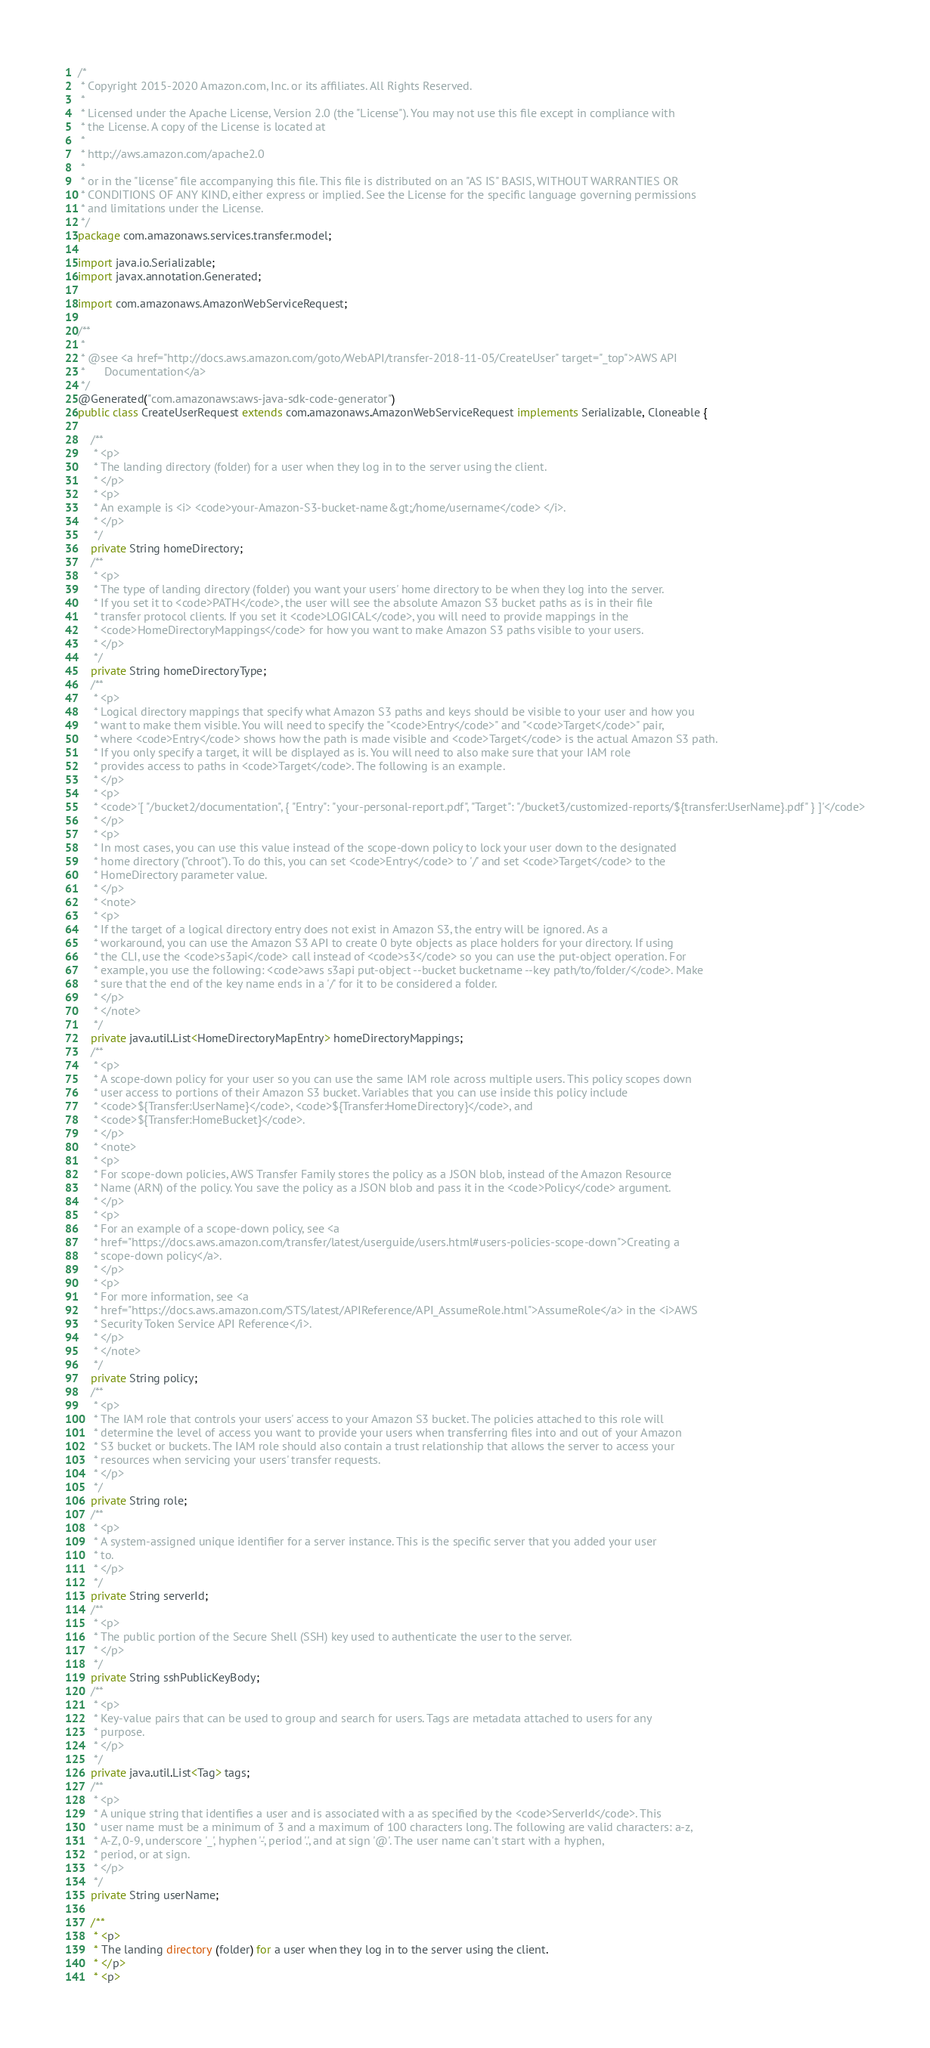<code> <loc_0><loc_0><loc_500><loc_500><_Java_>/*
 * Copyright 2015-2020 Amazon.com, Inc. or its affiliates. All Rights Reserved.
 * 
 * Licensed under the Apache License, Version 2.0 (the "License"). You may not use this file except in compliance with
 * the License. A copy of the License is located at
 * 
 * http://aws.amazon.com/apache2.0
 * 
 * or in the "license" file accompanying this file. This file is distributed on an "AS IS" BASIS, WITHOUT WARRANTIES OR
 * CONDITIONS OF ANY KIND, either express or implied. See the License for the specific language governing permissions
 * and limitations under the License.
 */
package com.amazonaws.services.transfer.model;

import java.io.Serializable;
import javax.annotation.Generated;

import com.amazonaws.AmazonWebServiceRequest;

/**
 * 
 * @see <a href="http://docs.aws.amazon.com/goto/WebAPI/transfer-2018-11-05/CreateUser" target="_top">AWS API
 *      Documentation</a>
 */
@Generated("com.amazonaws:aws-java-sdk-code-generator")
public class CreateUserRequest extends com.amazonaws.AmazonWebServiceRequest implements Serializable, Cloneable {

    /**
     * <p>
     * The landing directory (folder) for a user when they log in to the server using the client.
     * </p>
     * <p>
     * An example is <i> <code>your-Amazon-S3-bucket-name&gt;/home/username</code> </i>.
     * </p>
     */
    private String homeDirectory;
    /**
     * <p>
     * The type of landing directory (folder) you want your users' home directory to be when they log into the server.
     * If you set it to <code>PATH</code>, the user will see the absolute Amazon S3 bucket paths as is in their file
     * transfer protocol clients. If you set it <code>LOGICAL</code>, you will need to provide mappings in the
     * <code>HomeDirectoryMappings</code> for how you want to make Amazon S3 paths visible to your users.
     * </p>
     */
    private String homeDirectoryType;
    /**
     * <p>
     * Logical directory mappings that specify what Amazon S3 paths and keys should be visible to your user and how you
     * want to make them visible. You will need to specify the "<code>Entry</code>" and "<code>Target</code>" pair,
     * where <code>Entry</code> shows how the path is made visible and <code>Target</code> is the actual Amazon S3 path.
     * If you only specify a target, it will be displayed as is. You will need to also make sure that your IAM role
     * provides access to paths in <code>Target</code>. The following is an example.
     * </p>
     * <p>
     * <code>'[ "/bucket2/documentation", { "Entry": "your-personal-report.pdf", "Target": "/bucket3/customized-reports/${transfer:UserName}.pdf" } ]'</code>
     * </p>
     * <p>
     * In most cases, you can use this value instead of the scope-down policy to lock your user down to the designated
     * home directory ("chroot"). To do this, you can set <code>Entry</code> to '/' and set <code>Target</code> to the
     * HomeDirectory parameter value.
     * </p>
     * <note>
     * <p>
     * If the target of a logical directory entry does not exist in Amazon S3, the entry will be ignored. As a
     * workaround, you can use the Amazon S3 API to create 0 byte objects as place holders for your directory. If using
     * the CLI, use the <code>s3api</code> call instead of <code>s3</code> so you can use the put-object operation. For
     * example, you use the following: <code>aws s3api put-object --bucket bucketname --key path/to/folder/</code>. Make
     * sure that the end of the key name ends in a '/' for it to be considered a folder.
     * </p>
     * </note>
     */
    private java.util.List<HomeDirectoryMapEntry> homeDirectoryMappings;
    /**
     * <p>
     * A scope-down policy for your user so you can use the same IAM role across multiple users. This policy scopes down
     * user access to portions of their Amazon S3 bucket. Variables that you can use inside this policy include
     * <code>${Transfer:UserName}</code>, <code>${Transfer:HomeDirectory}</code>, and
     * <code>${Transfer:HomeBucket}</code>.
     * </p>
     * <note>
     * <p>
     * For scope-down policies, AWS Transfer Family stores the policy as a JSON blob, instead of the Amazon Resource
     * Name (ARN) of the policy. You save the policy as a JSON blob and pass it in the <code>Policy</code> argument.
     * </p>
     * <p>
     * For an example of a scope-down policy, see <a
     * href="https://docs.aws.amazon.com/transfer/latest/userguide/users.html#users-policies-scope-down">Creating a
     * scope-down policy</a>.
     * </p>
     * <p>
     * For more information, see <a
     * href="https://docs.aws.amazon.com/STS/latest/APIReference/API_AssumeRole.html">AssumeRole</a> in the <i>AWS
     * Security Token Service API Reference</i>.
     * </p>
     * </note>
     */
    private String policy;
    /**
     * <p>
     * The IAM role that controls your users' access to your Amazon S3 bucket. The policies attached to this role will
     * determine the level of access you want to provide your users when transferring files into and out of your Amazon
     * S3 bucket or buckets. The IAM role should also contain a trust relationship that allows the server to access your
     * resources when servicing your users' transfer requests.
     * </p>
     */
    private String role;
    /**
     * <p>
     * A system-assigned unique identifier for a server instance. This is the specific server that you added your user
     * to.
     * </p>
     */
    private String serverId;
    /**
     * <p>
     * The public portion of the Secure Shell (SSH) key used to authenticate the user to the server.
     * </p>
     */
    private String sshPublicKeyBody;
    /**
     * <p>
     * Key-value pairs that can be used to group and search for users. Tags are metadata attached to users for any
     * purpose.
     * </p>
     */
    private java.util.List<Tag> tags;
    /**
     * <p>
     * A unique string that identifies a user and is associated with a as specified by the <code>ServerId</code>. This
     * user name must be a minimum of 3 and a maximum of 100 characters long. The following are valid characters: a-z,
     * A-Z, 0-9, underscore '_', hyphen '-', period '.', and at sign '@'. The user name can't start with a hyphen,
     * period, or at sign.
     * </p>
     */
    private String userName;

    /**
     * <p>
     * The landing directory (folder) for a user when they log in to the server using the client.
     * </p>
     * <p></code> 